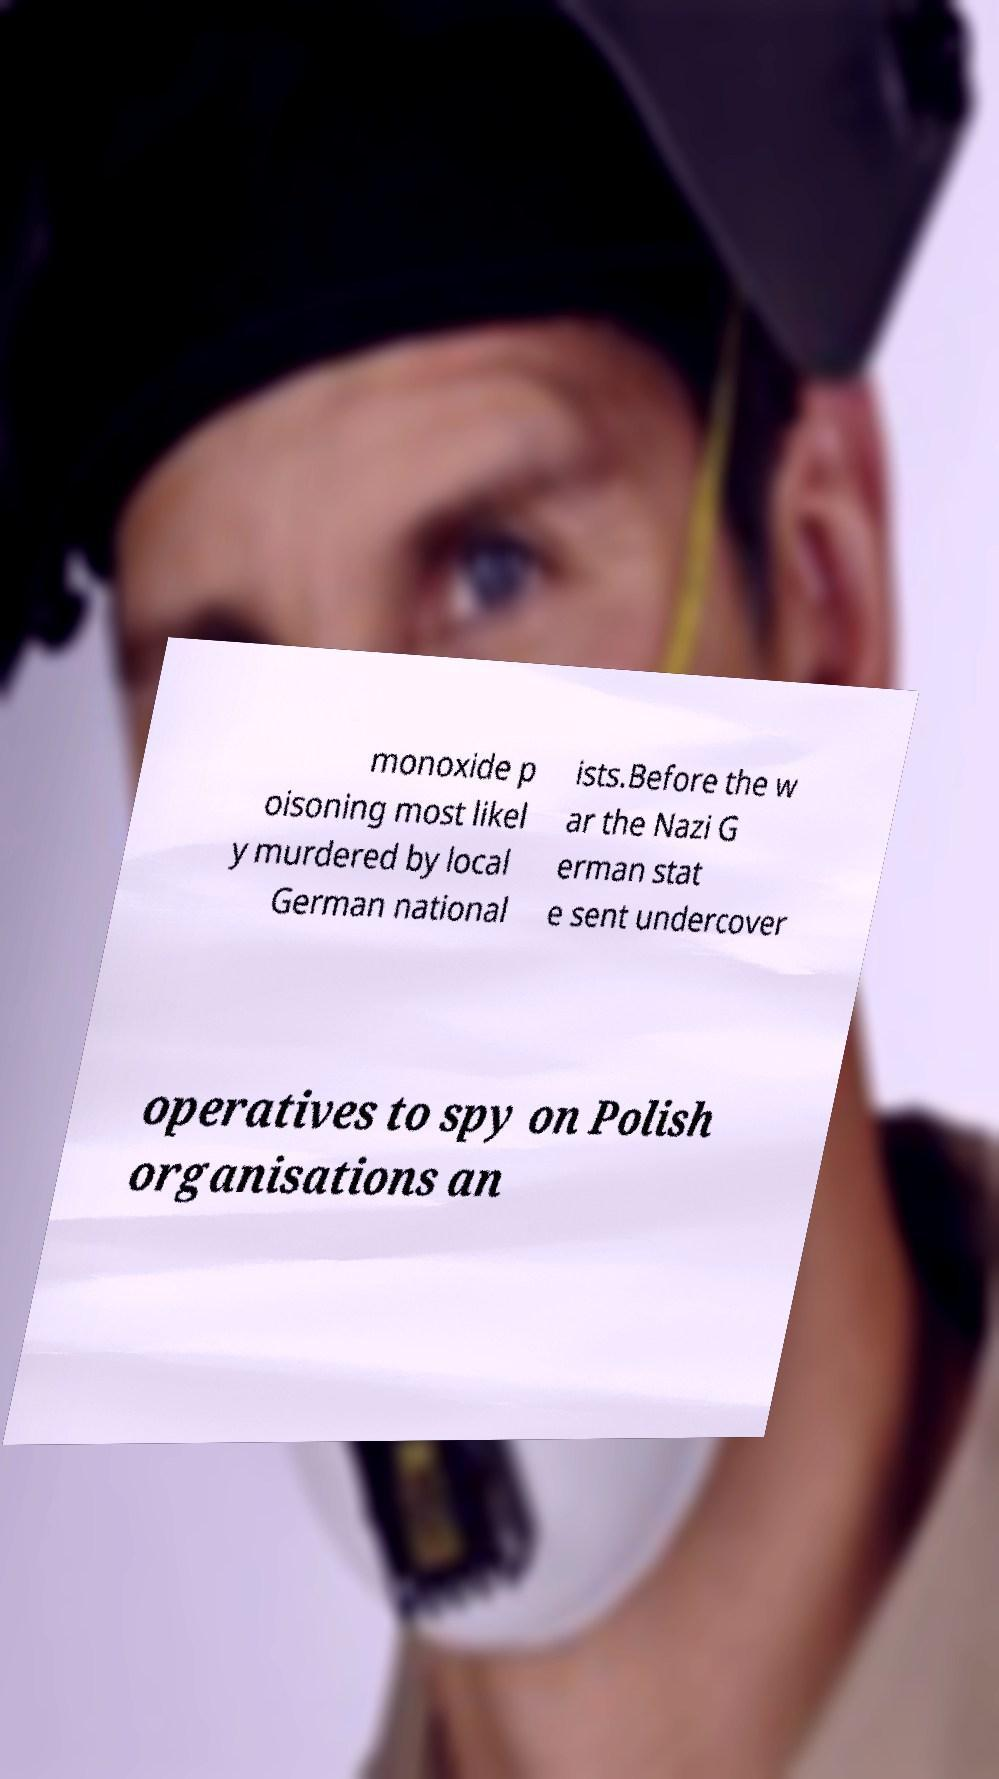For documentation purposes, I need the text within this image transcribed. Could you provide that? monoxide p oisoning most likel y murdered by local German national ists.Before the w ar the Nazi G erman stat e sent undercover operatives to spy on Polish organisations an 